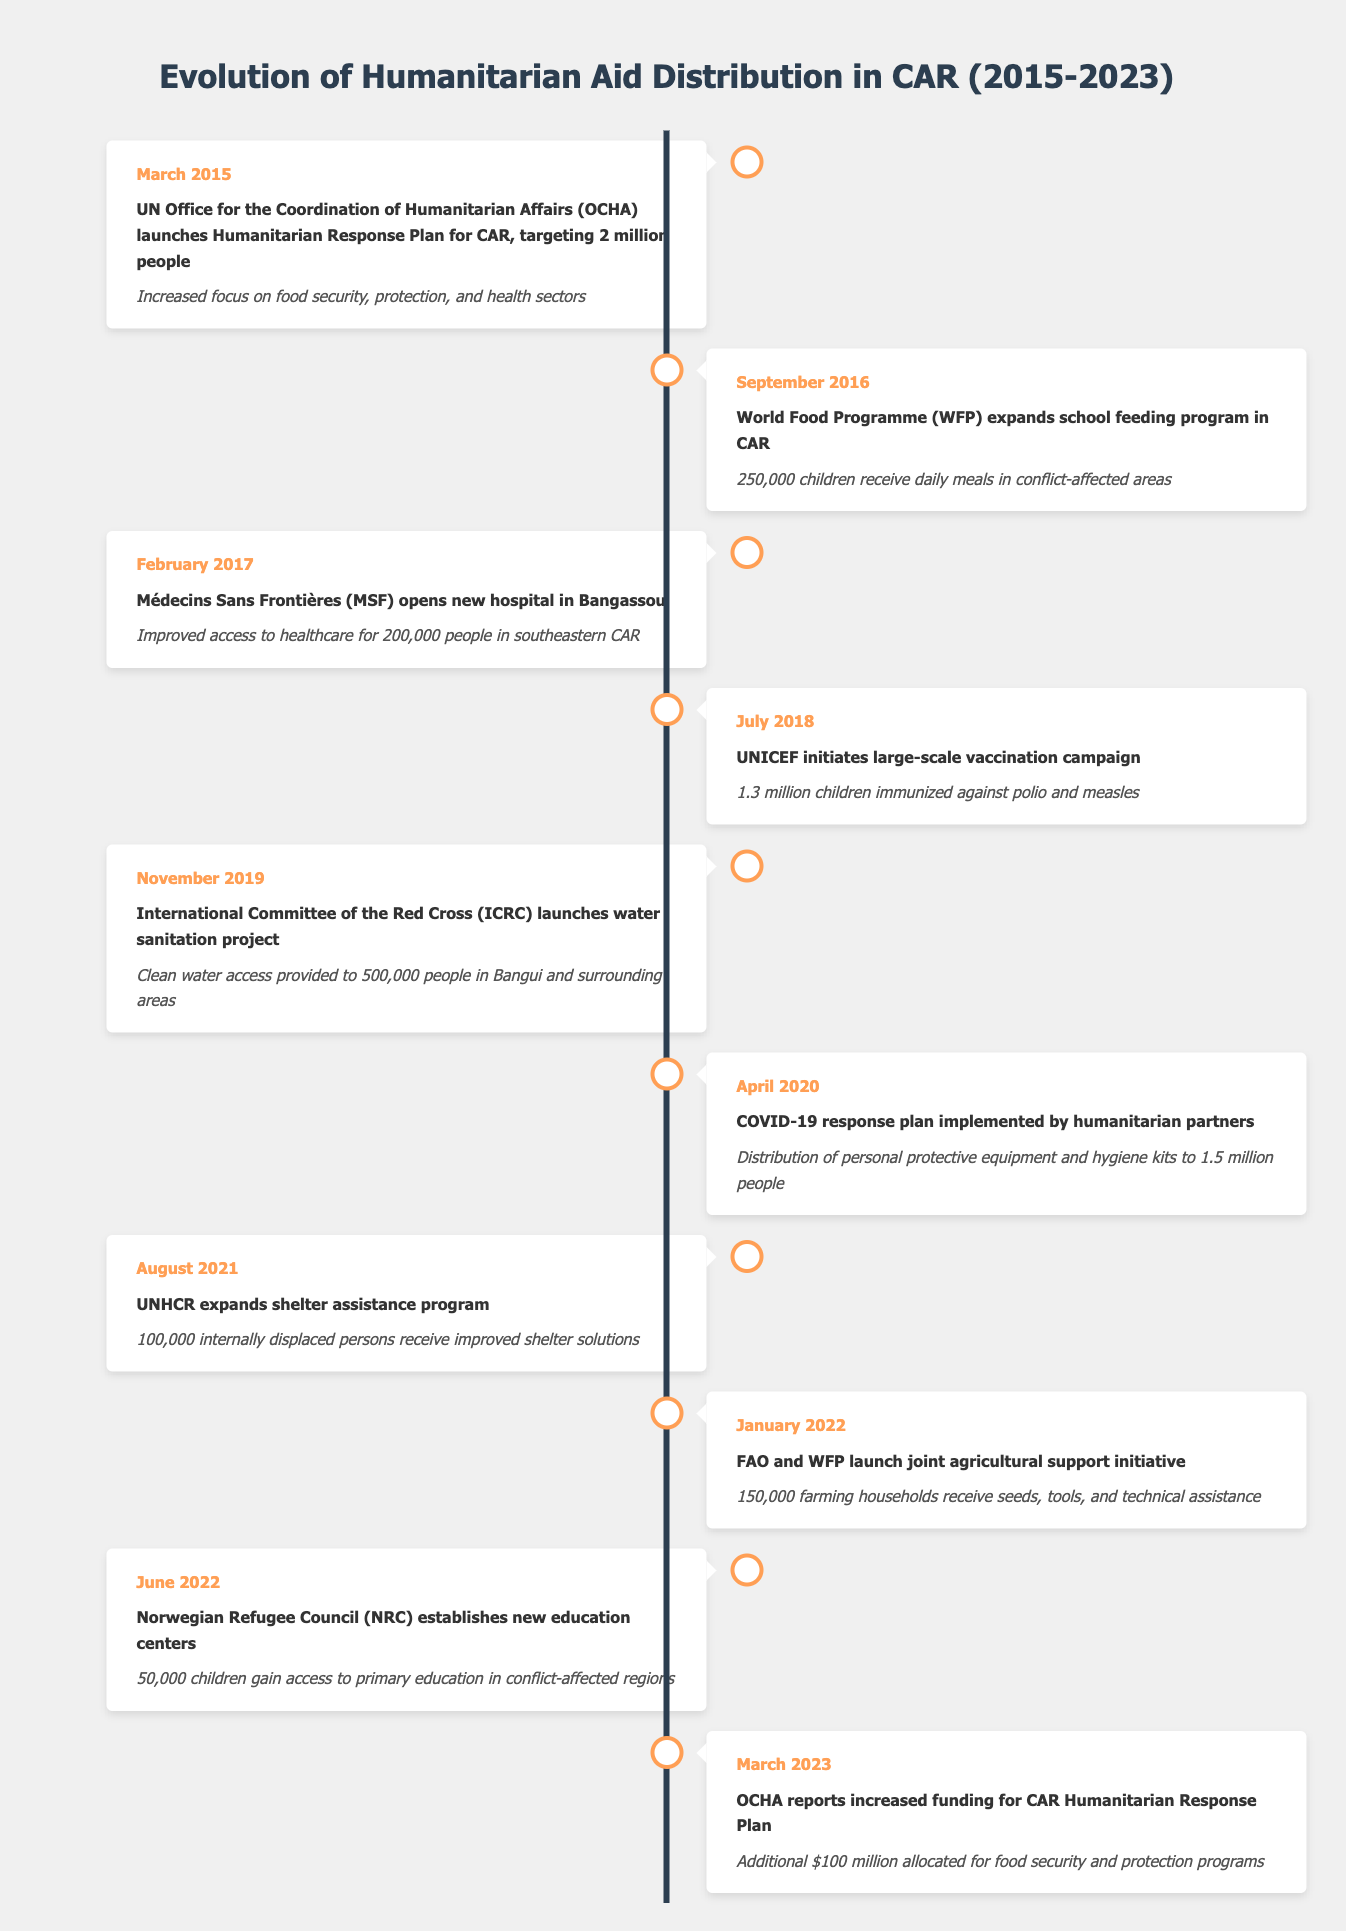What event took place in July 2018? According to the table, in July 2018, UNICEF initiated a large-scale vaccination campaign.
Answer: UNICEF initiated a large-scale vaccination campaign How many children were immunized in the July 2018 vaccination campaign? The table states that 1.3 million children were immunized against polio and measles during the campaign initiated by UNICEF.
Answer: 1.3 million children Did the ICRC launch a water sanitation project before April 2020? Yes, the ICRC launched a water sanitation project in November 2019, which is before April 2020.
Answer: Yes What is the total number of people receiving assistance from the events listed in March 2015 and April 2020? In March 2015, 2 million people were targeted in the Humanitarian Response Plan, and in April 2020, 1.5 million people received personal protective equipment and hygiene kits. Adding these numbers gives 2 million + 1.5 million = 3.5 million people.
Answer: 3.5 million people How many children gained access to primary education by June 2022? The table indicates that by June 2022, 50,000 children gained access to primary education as a result of the Norwegian Refugee Council establishing new education centers.
Answer: 50,000 children Which organization was responsible for the agricultural support initiative launched in January 2022? The FAO and WFP collaborated to launch the joint agricultural support initiative in January 2022.
Answer: FAO and WFP What was the impact of the COVID-19 response plan in April 2020? The response plan led to the distribution of personal protective equipment and hygiene kits to 1.5 million people.
Answer: Distribution of protective equipment and hygiene kits to 1.5 million people How much additional funding was reported for the CAR Humanitarian Response Plan in March 2023? According to the table, OCHA reported an additional $100 million allocated for food security and protection programs in March 2023.
Answer: $100 million 